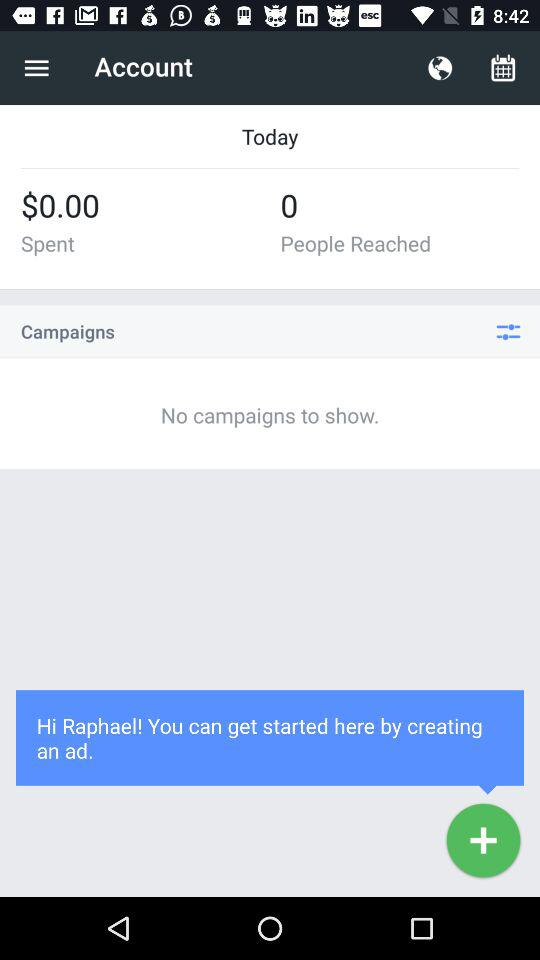How much $ has been spent? There is $0.00 that has been spent. 